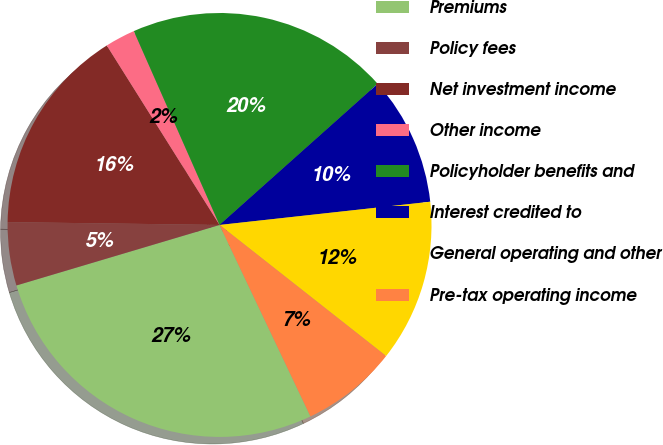Convert chart. <chart><loc_0><loc_0><loc_500><loc_500><pie_chart><fcel>Premiums<fcel>Policy fees<fcel>Net investment income<fcel>Other income<fcel>Policyholder benefits and<fcel>Interest credited to<fcel>General operating and other<fcel>Pre-tax operating income<nl><fcel>27.45%<fcel>4.82%<fcel>15.86%<fcel>2.3%<fcel>20.03%<fcel>9.85%<fcel>12.36%<fcel>7.33%<nl></chart> 